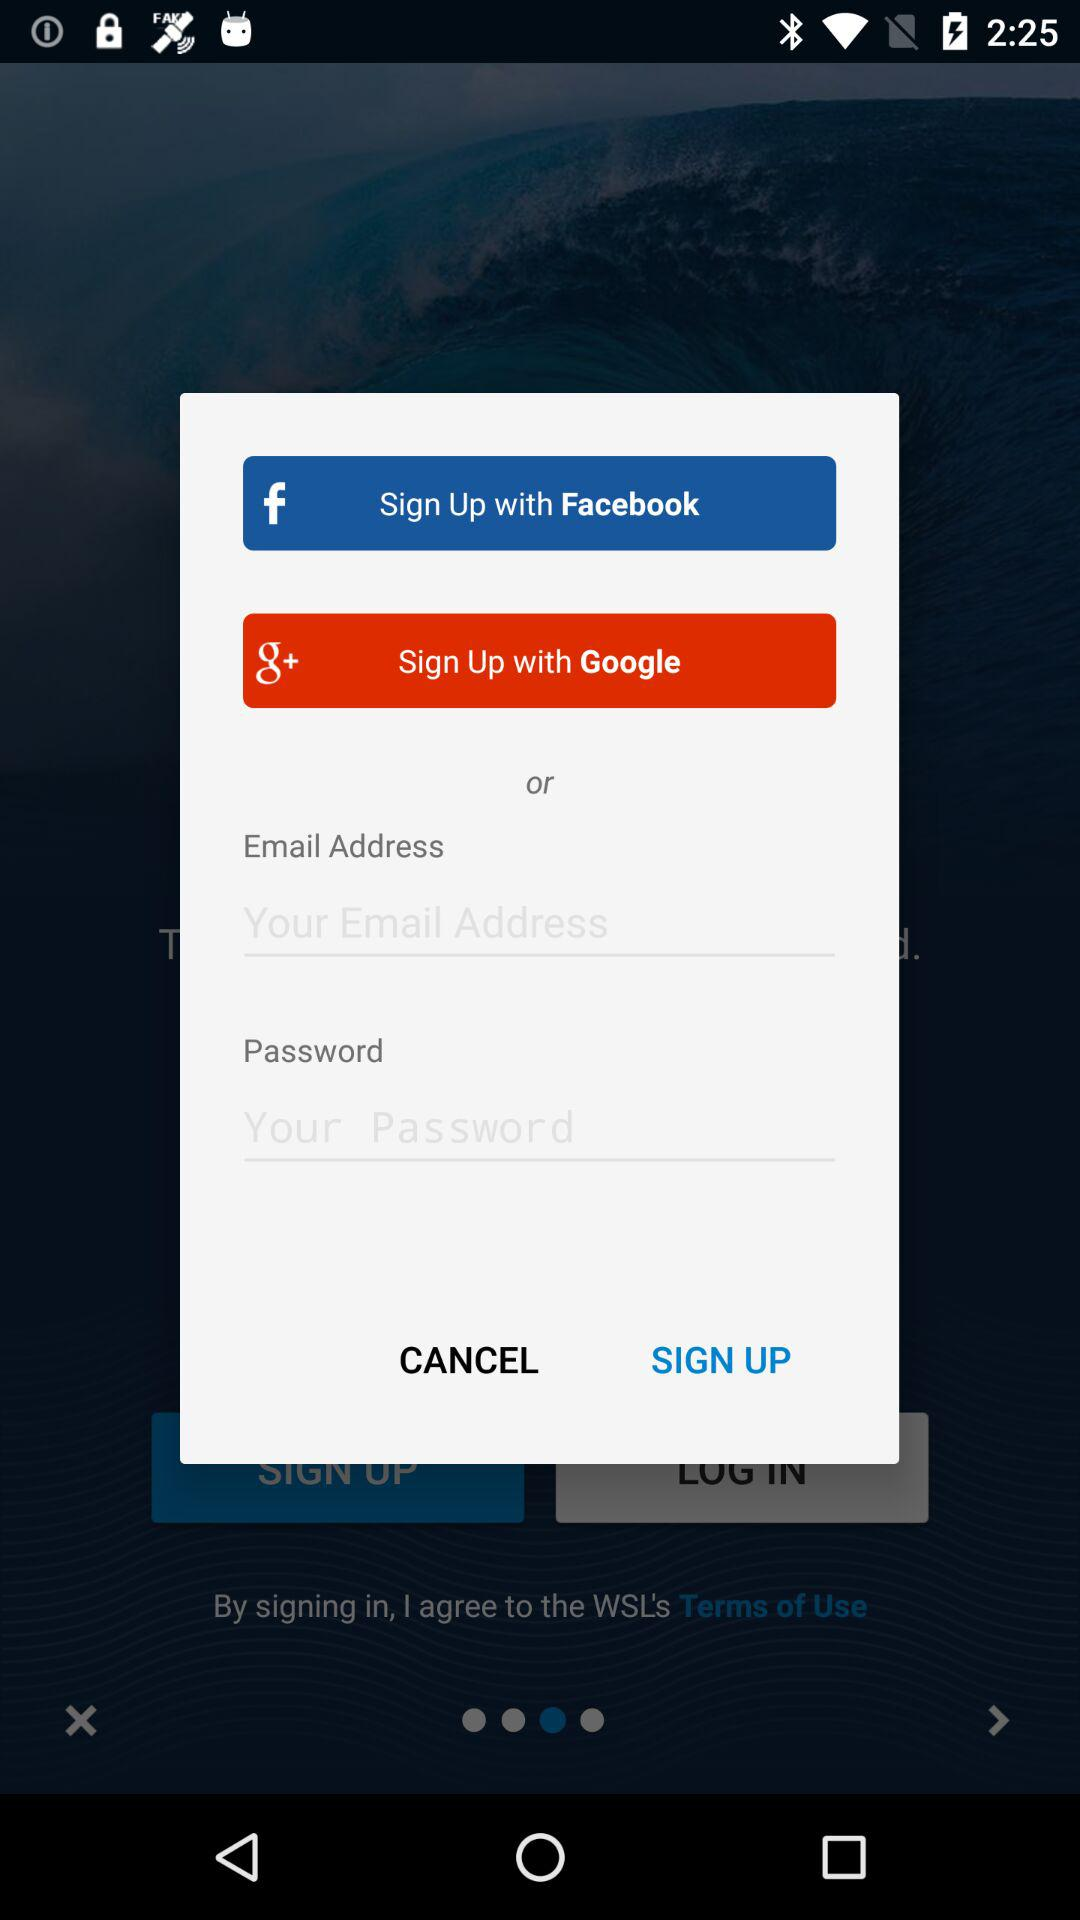What are the options for signing up? The options for signing up are "Facebook", "Google" and "Email Address". 